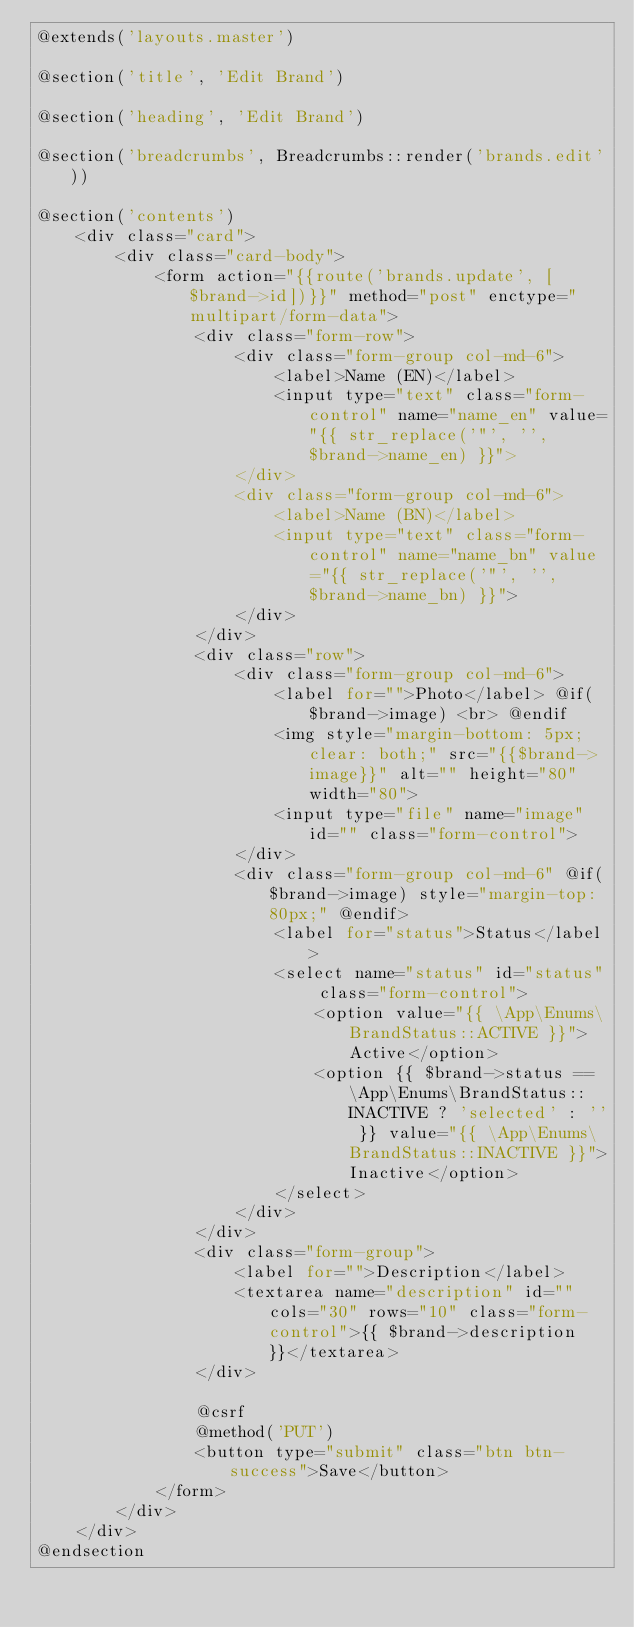<code> <loc_0><loc_0><loc_500><loc_500><_PHP_>@extends('layouts.master')

@section('title', 'Edit Brand')

@section('heading', 'Edit Brand')

@section('breadcrumbs', Breadcrumbs::render('brands.edit'))

@section('contents')
    <div class="card">
        <div class="card-body">
            <form action="{{route('brands.update', [$brand->id])}}" method="post" enctype="multipart/form-data">
                <div class="form-row">
                    <div class="form-group col-md-6">
                        <label>Name (EN)</label>
                        <input type="text" class="form-control" name="name_en" value="{{ str_replace('"', '', $brand->name_en) }}">
                    </div>
                    <div class="form-group col-md-6">
                        <label>Name (BN)</label>
                        <input type="text" class="form-control" name="name_bn" value="{{ str_replace('"', '', $brand->name_bn) }}">
                    </div>
                </div>
                <div class="row">
                    <div class="form-group col-md-6">
                        <label for="">Photo</label> @if($brand->image) <br> @endif
                        <img style="margin-bottom: 5px; clear: both;" src="{{$brand->image}}" alt="" height="80" width="80">
                        <input type="file" name="image" id="" class="form-control">
                    </div>
                    <div class="form-group col-md-6" @if($brand->image) style="margin-top: 80px;" @endif>
                        <label for="status">Status</label>
                        <select name="status" id="status" class="form-control">
                            <option value="{{ \App\Enums\BrandStatus::ACTIVE }}">Active</option>
                            <option {{ $brand->status == \App\Enums\BrandStatus::INACTIVE ? 'selected' : '' }} value="{{ \App\Enums\BrandStatus::INACTIVE }}">Inactive</option>
                        </select>
                    </div>
                </div>
                <div class="form-group">
                    <label for="">Description</label>
                    <textarea name="description" id="" cols="30" rows="10" class="form-control">{{ $brand->description }}</textarea>
                </div>

                @csrf
                @method('PUT')
                <button type="submit" class="btn btn-success">Save</button>
            </form>
        </div>
    </div>
@endsection
</code> 